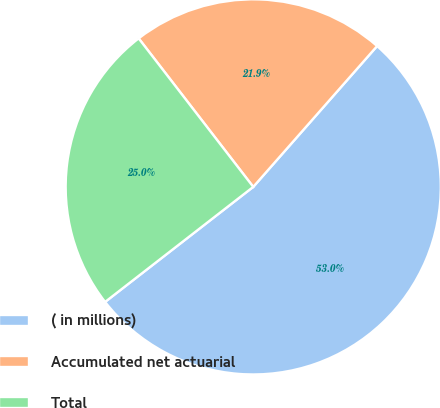Convert chart to OTSL. <chart><loc_0><loc_0><loc_500><loc_500><pie_chart><fcel>( in millions)<fcel>Accumulated net actuarial<fcel>Total<nl><fcel>53.01%<fcel>21.94%<fcel>25.05%<nl></chart> 